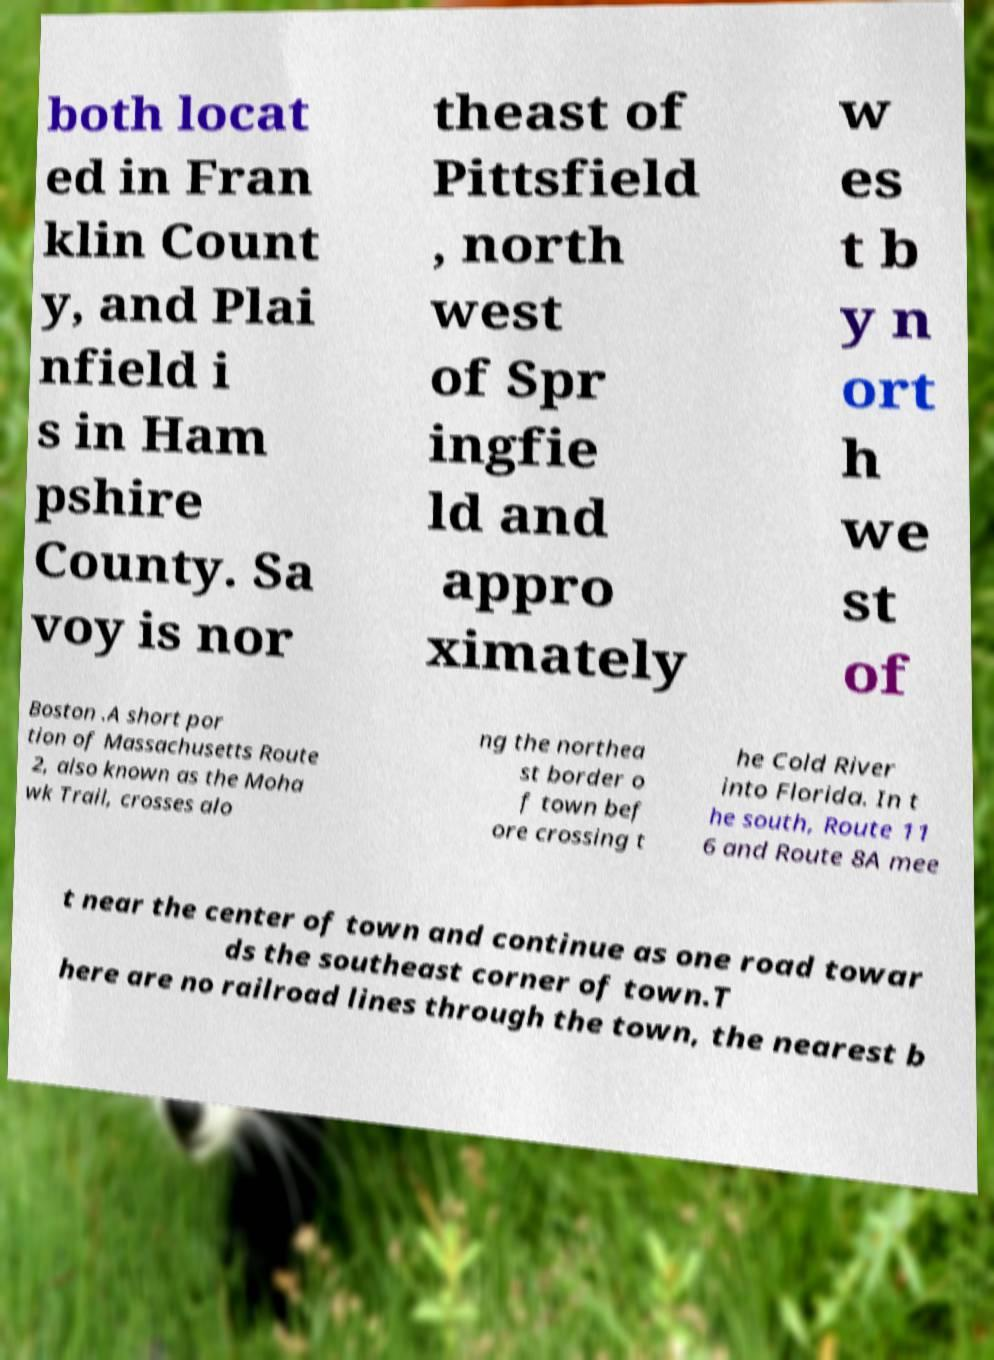I need the written content from this picture converted into text. Can you do that? both locat ed in Fran klin Count y, and Plai nfield i s in Ham pshire County. Sa voy is nor theast of Pittsfield , north west of Spr ingfie ld and appro ximately w es t b y n ort h we st of Boston .A short por tion of Massachusetts Route 2, also known as the Moha wk Trail, crosses alo ng the northea st border o f town bef ore crossing t he Cold River into Florida. In t he south, Route 11 6 and Route 8A mee t near the center of town and continue as one road towar ds the southeast corner of town.T here are no railroad lines through the town, the nearest b 